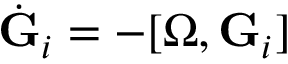Convert formula to latex. <formula><loc_0><loc_0><loc_500><loc_500>\dot { G } _ { i } = - [ { \boldsymbol \Omega } , { G } _ { i } ]</formula> 